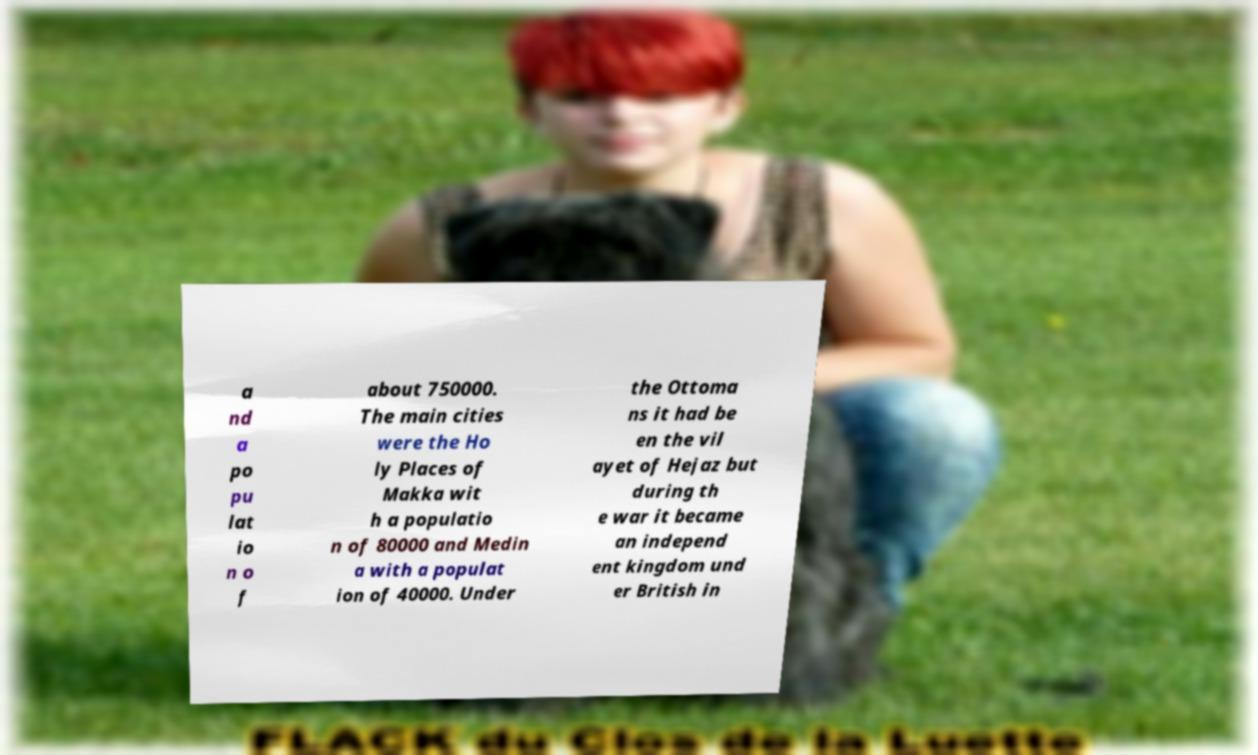Please identify and transcribe the text found in this image. a nd a po pu lat io n o f about 750000. The main cities were the Ho ly Places of Makka wit h a populatio n of 80000 and Medin a with a populat ion of 40000. Under the Ottoma ns it had be en the vil ayet of Hejaz but during th e war it became an independ ent kingdom und er British in 